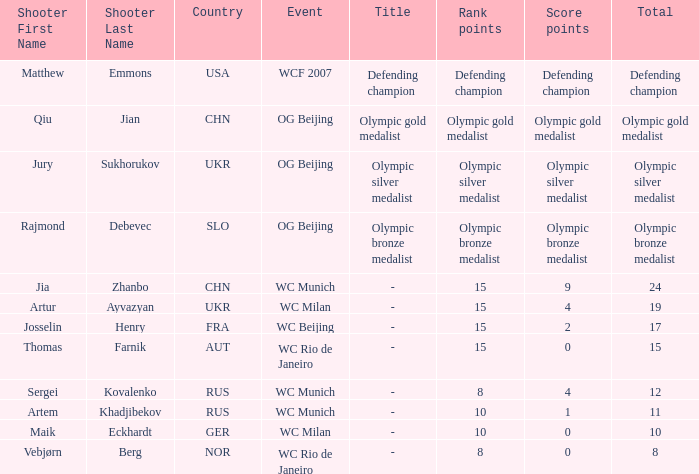Who is the shooter with 15 rank points, and 0 score points? Thomas Farnik ( AUT ). 